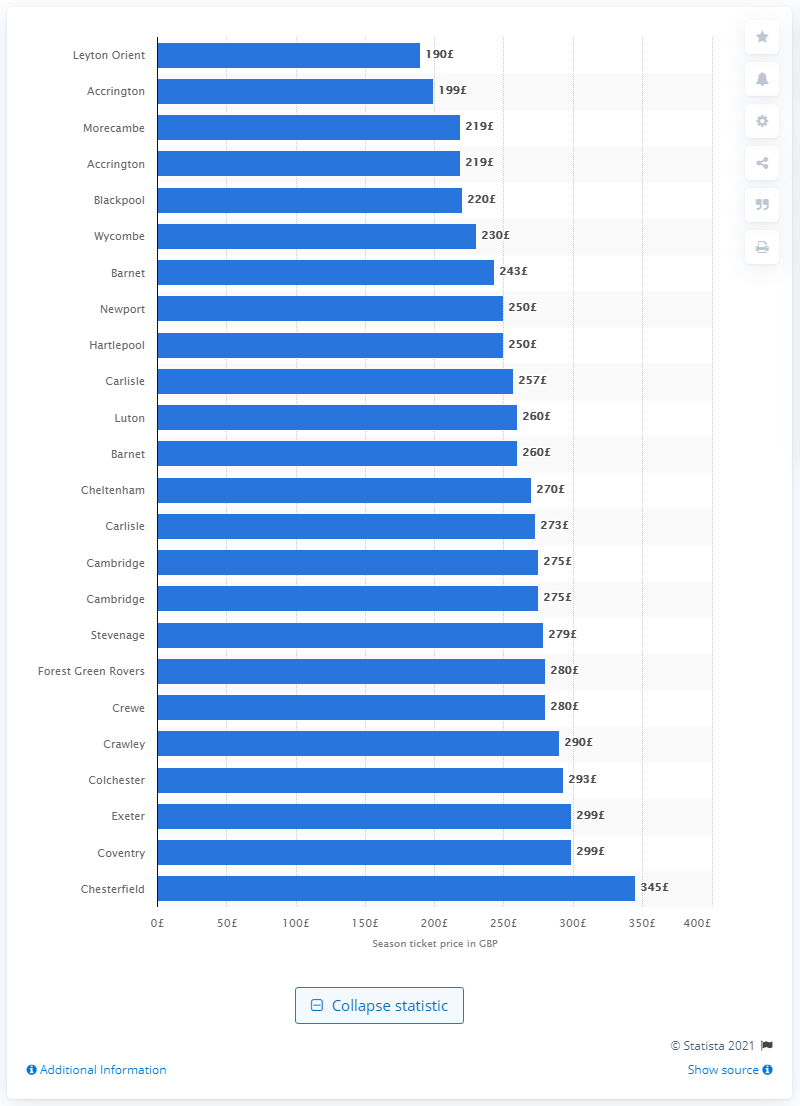Draw attention to some important aspects in this diagram. According to data from the 2017/18 season, Accrington sold the cheapest season ticket among all teams in the league. In the 2017/18 season, Accrington sold the cheapest season ticket out of all the teams. In the 2017/18 season, Accrington sold the cheapest season ticket out of all the teams participating in the league. 